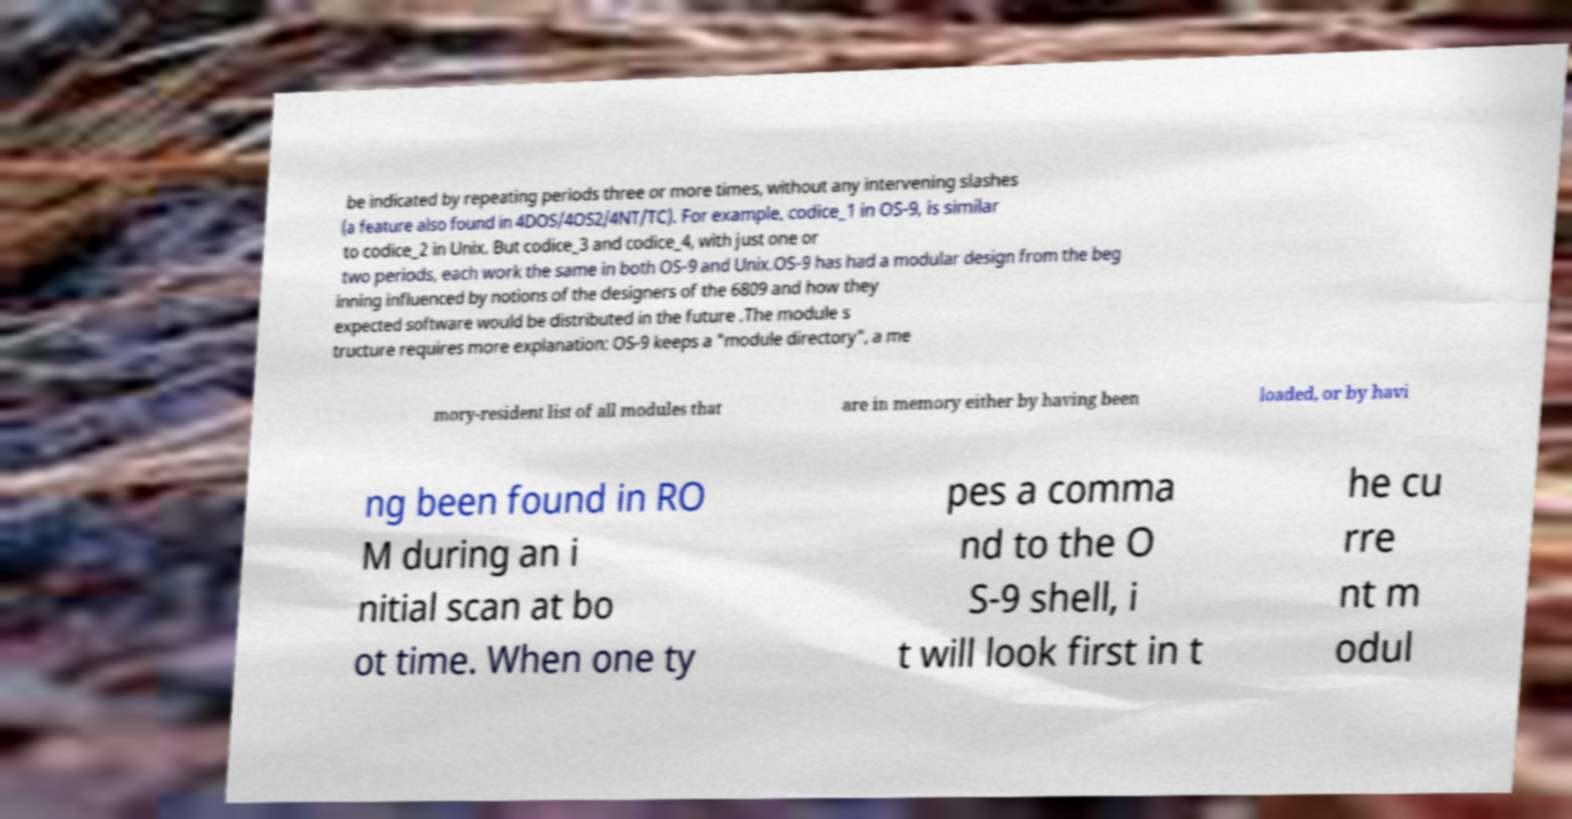For documentation purposes, I need the text within this image transcribed. Could you provide that? be indicated by repeating periods three or more times, without any intervening slashes (a feature also found in 4DOS/4OS2/4NT/TC). For example, codice_1 in OS-9, is similar to codice_2 in Unix. But codice_3 and codice_4, with just one or two periods, each work the same in both OS-9 and Unix.OS-9 has had a modular design from the beg inning influenced by notions of the designers of the 6809 and how they expected software would be distributed in the future .The module s tructure requires more explanation: OS-9 keeps a "module directory", a me mory-resident list of all modules that are in memory either by having been loaded, or by havi ng been found in RO M during an i nitial scan at bo ot time. When one ty pes a comma nd to the O S-9 shell, i t will look first in t he cu rre nt m odul 